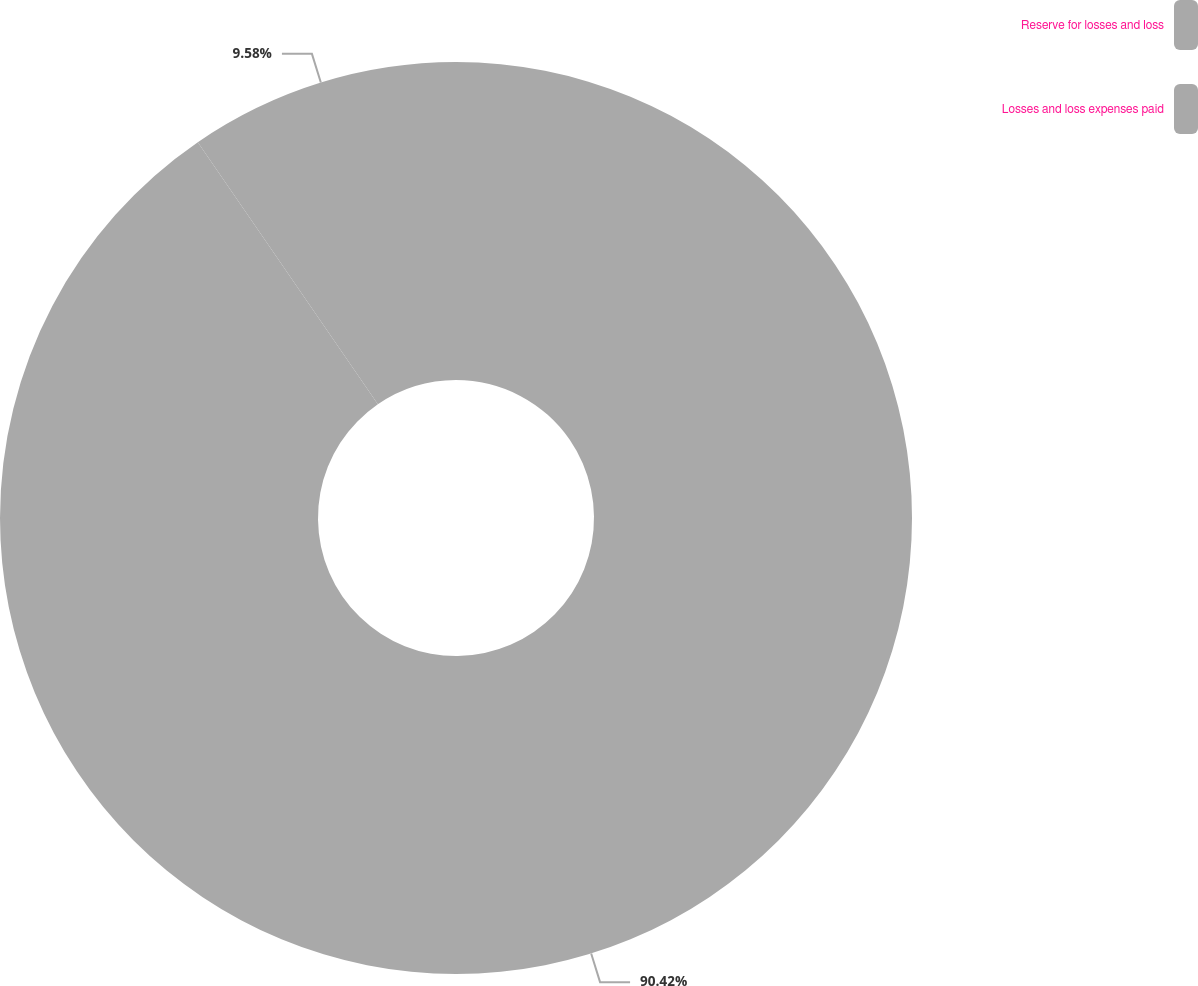Convert chart to OTSL. <chart><loc_0><loc_0><loc_500><loc_500><pie_chart><fcel>Reserve for losses and loss<fcel>Losses and loss expenses paid<nl><fcel>90.42%<fcel>9.58%<nl></chart> 